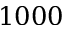<formula> <loc_0><loc_0><loc_500><loc_500>1 0 0 0</formula> 